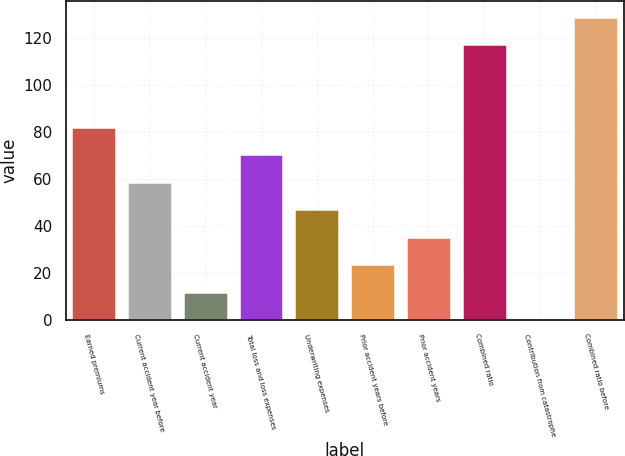Convert chart to OTSL. <chart><loc_0><loc_0><loc_500><loc_500><bar_chart><fcel>Earned premiums<fcel>Current accident year before<fcel>Current accident year<fcel>Total loss and loss expenses<fcel>Underwriting expenses<fcel>Prior accident years before<fcel>Prior accident years<fcel>Combined ratio<fcel>Contribution from catastrophe<fcel>Combined ratio before<nl><fcel>82.14<fcel>58.7<fcel>11.82<fcel>70.42<fcel>46.98<fcel>23.54<fcel>35.26<fcel>117.2<fcel>0.1<fcel>128.92<nl></chart> 